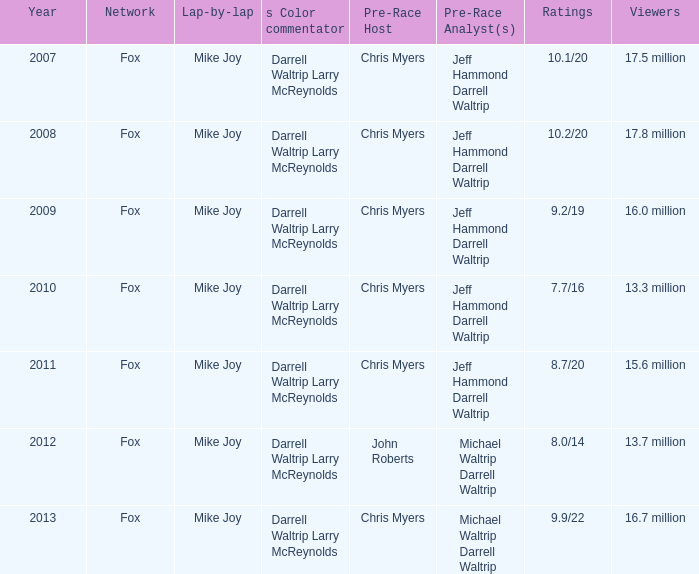How many Ratings did the 2013 Year have? 9.9/22. 